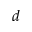Convert formula to latex. <formula><loc_0><loc_0><loc_500><loc_500>d</formula> 